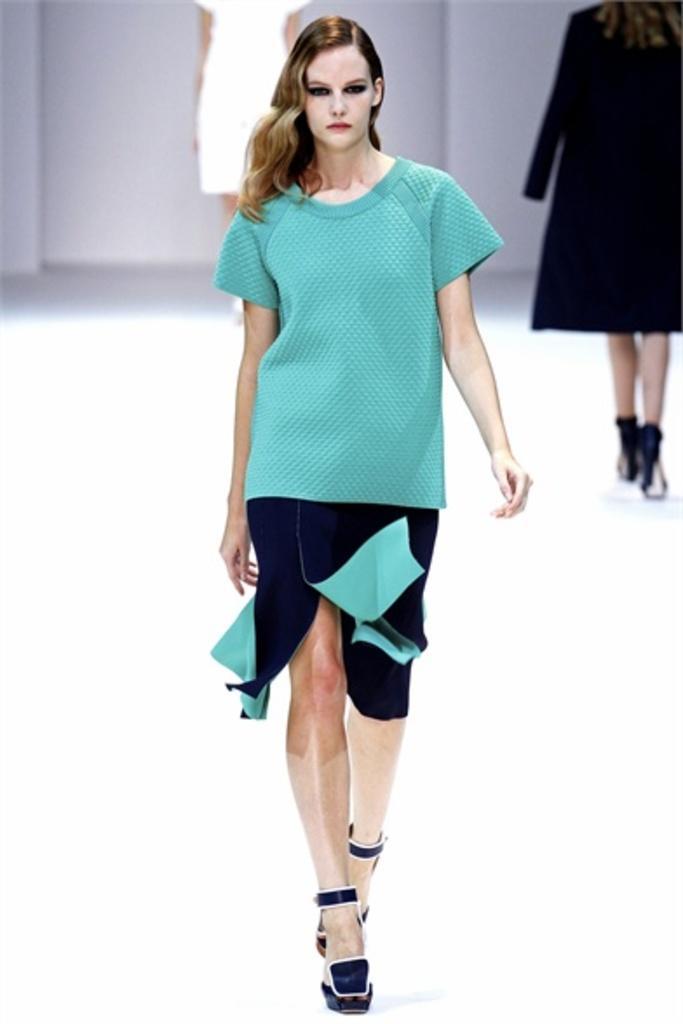Can you describe this image briefly? In this image we can see two women walking on the floor. On the backside we can see a woman standing. 